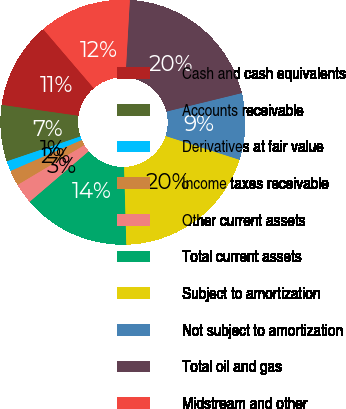<chart> <loc_0><loc_0><loc_500><loc_500><pie_chart><fcel>Cash and cash equivalents<fcel>Accounts receivable<fcel>Derivatives at fair value<fcel>Income taxes receivable<fcel>Other current assets<fcel>Total current assets<fcel>Subject to amortization<fcel>Not subject to amortization<fcel>Total oil and gas<fcel>Midstream and other<nl><fcel>11.49%<fcel>7.43%<fcel>1.35%<fcel>2.03%<fcel>2.7%<fcel>14.19%<fcel>19.59%<fcel>8.78%<fcel>20.27%<fcel>12.16%<nl></chart> 